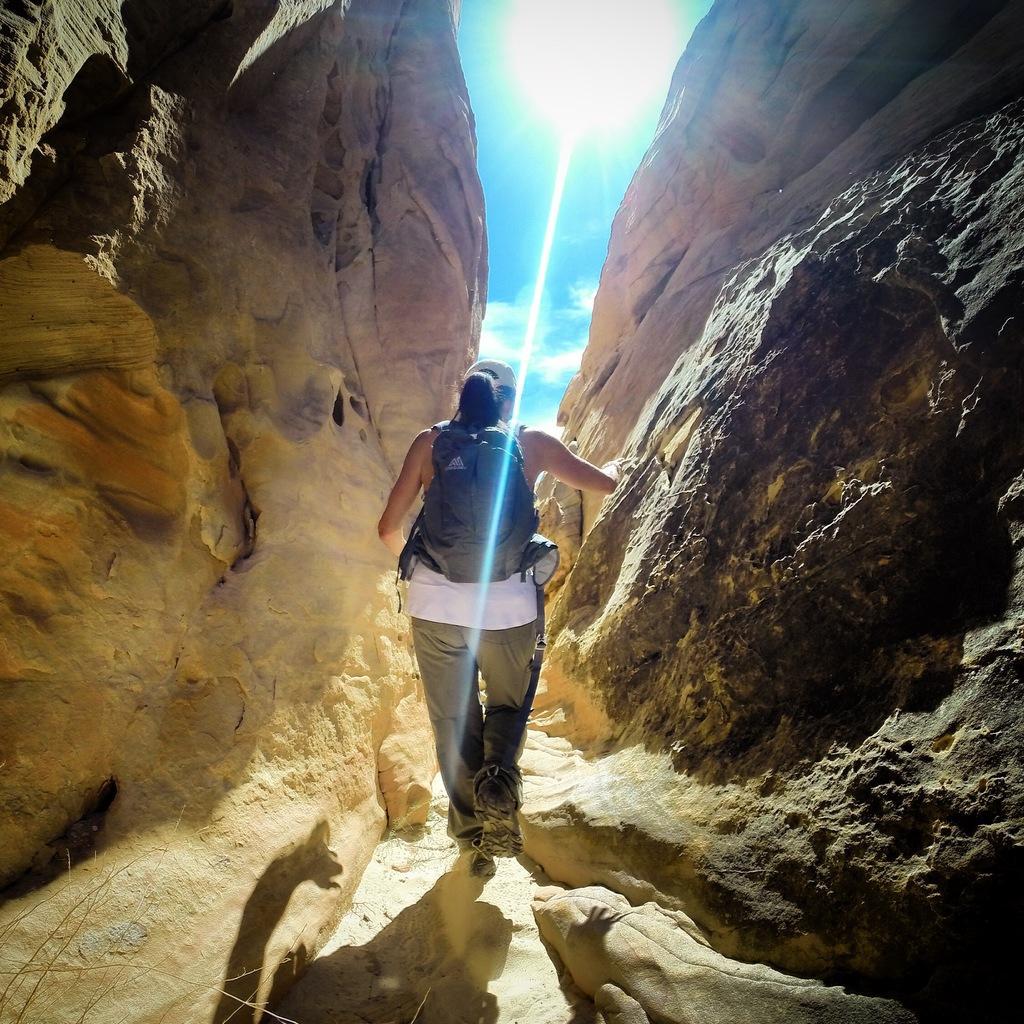In one or two sentences, can you explain what this image depicts? Here I can see a person wearing a bag, cap on the head and walking on the ground towards the back side. On the right and left side of the image I can see the rocks. At the top of the image I can see the sky along with the sun. 